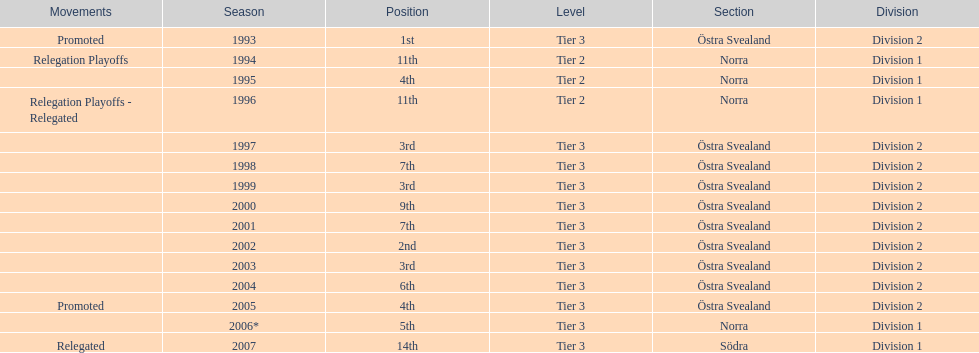What is listed under the movements column of the last season? Relegated. 